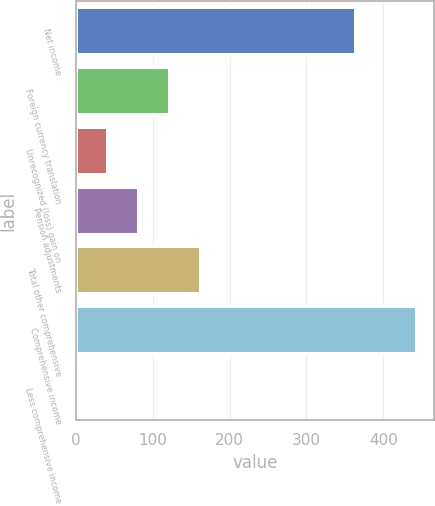<chart> <loc_0><loc_0><loc_500><loc_500><bar_chart><fcel>Net income<fcel>Foreign currency translation<fcel>Unrecognized (loss) gain on<fcel>Pension adjustments<fcel>Total other comprehensive<fcel>Comprehensive income<fcel>Less comprehensive income<nl><fcel>364<fcel>122.3<fcel>42.1<fcel>82.2<fcel>162.4<fcel>444.2<fcel>2<nl></chart> 